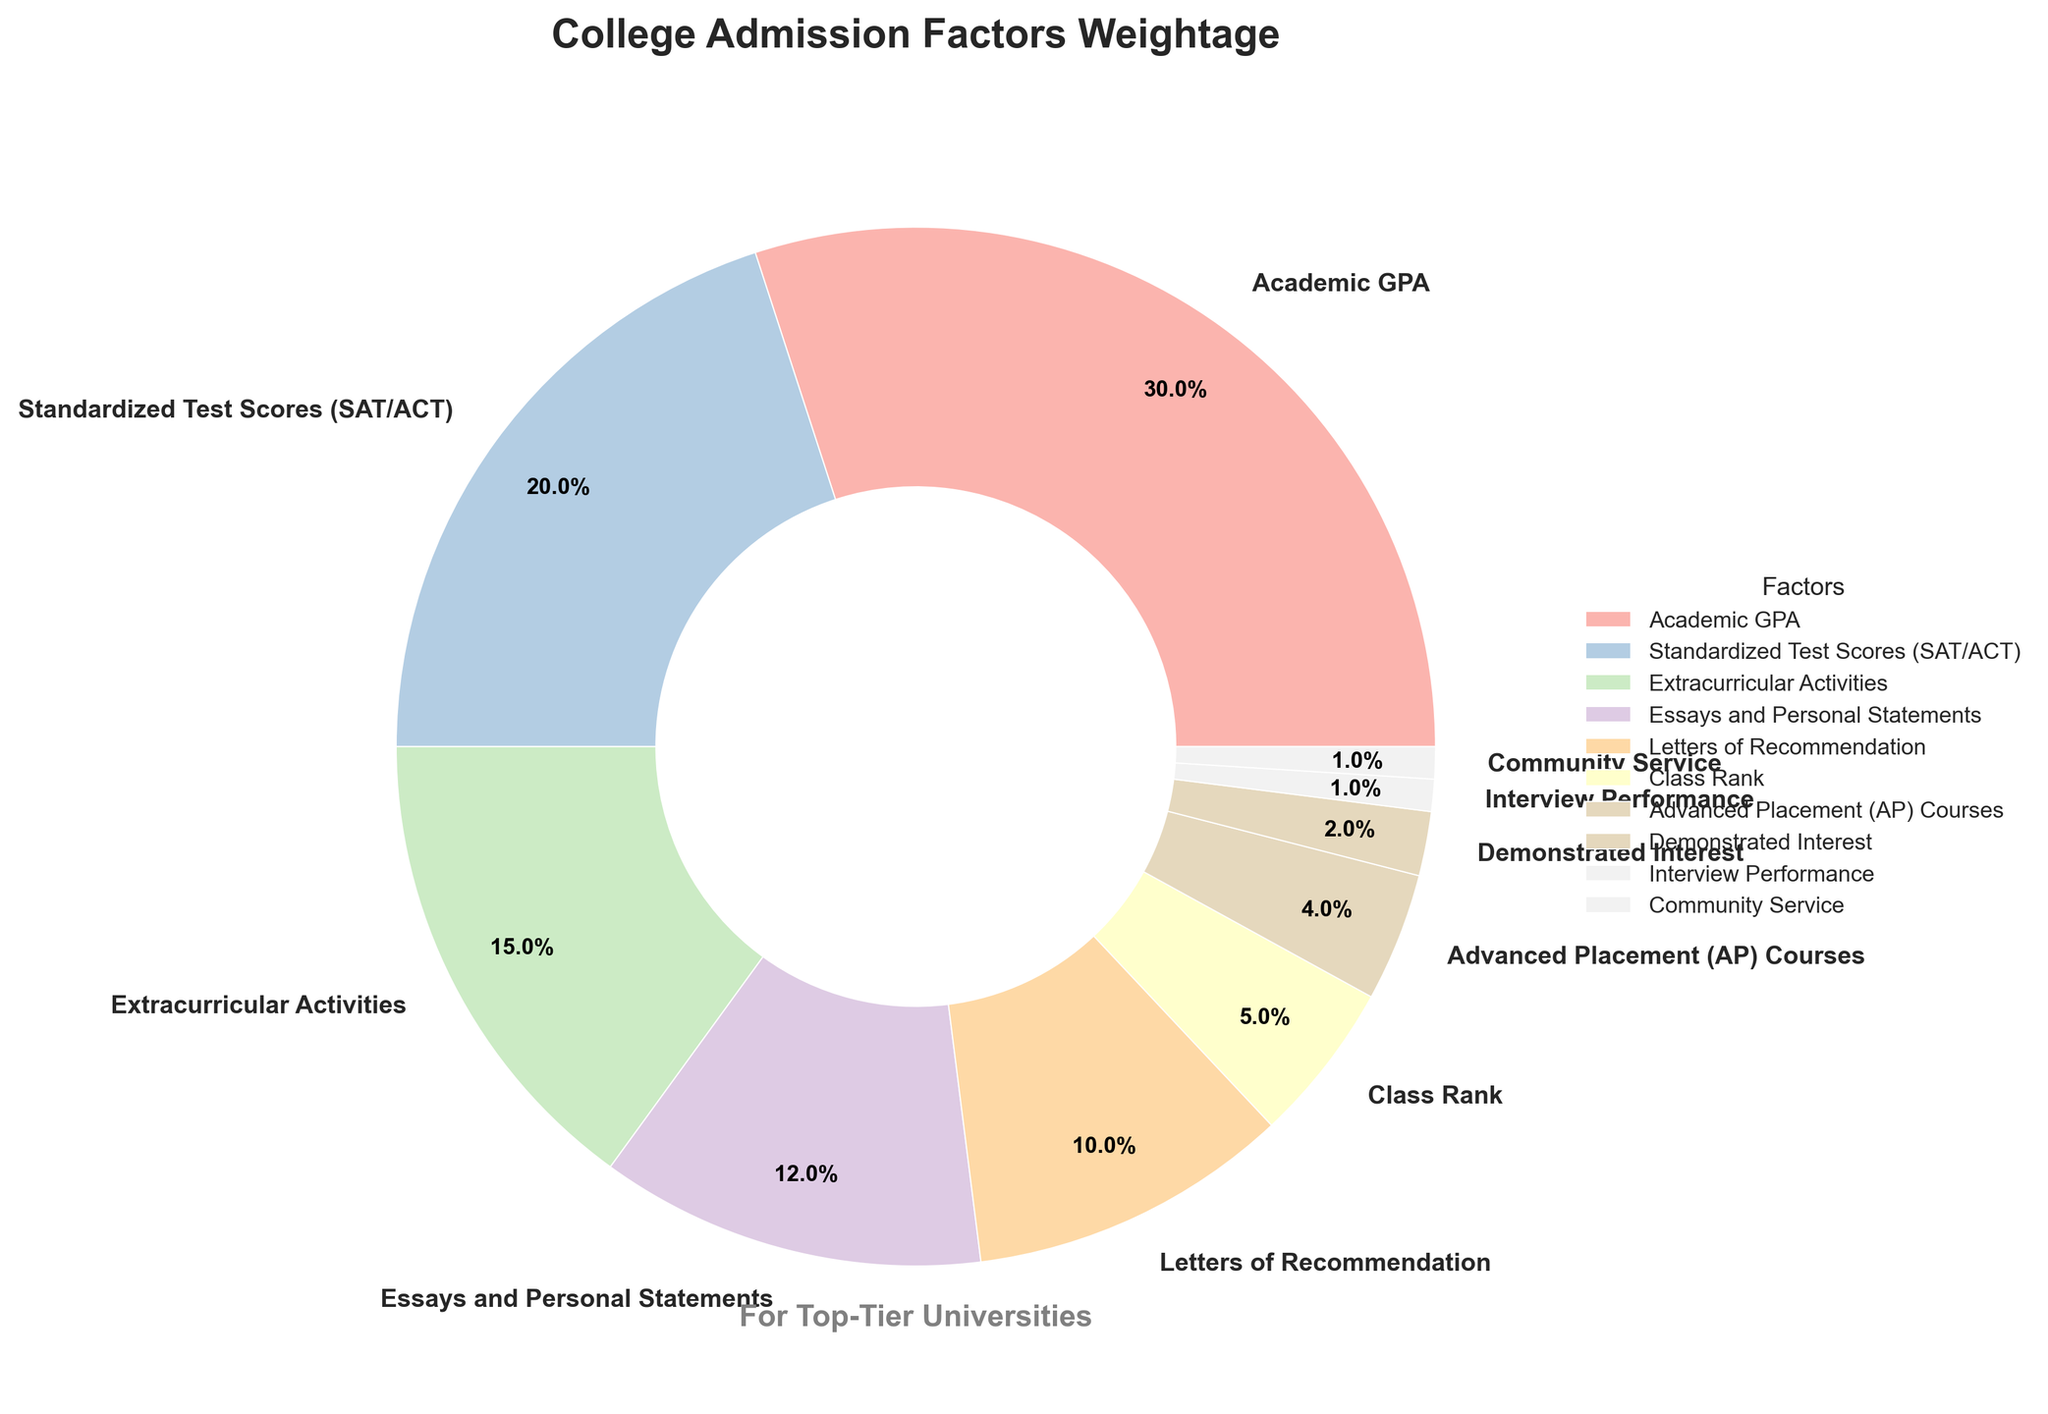What factor contributes the most to college admissions? The factor with the largest segment in the pie chart is "Academic GPA" with a percentage of 30%.
Answer: Academic GPA Which two factors together have the highest weightage percentage? "Academic GPA" (30%) and "Standardized Test Scores (SAT/ACT)" (20%) together have a combined percentage of 30% + 20% = 50%.
Answer: Academic GPA and Standardized Test Scores (SAT/ACT) What is the combined percentage of "Essays and Personal Statements," "Letters of Recommendation," and "Class Rank"? Add the percentages for each factor: "Essays and Personal Statements" (12%), "Letters of Recommendation" (10%), and "Class Rank" (5%). The total is 12% + 10% + 5% = 27%.
Answer: 27% Are "Extracurricular Activities" more important than "Advanced Placement (AP) Courses"? Yes, "Extracurricular Activities" have a percentage of 15%, while "Advanced Placement (AP) Courses" have a lower percentage of 4%.
Answer: Yes Which factor is indicated by the smallest segment in the pie chart? The factor with the smallest segment is "Community Service" and "Interview Performance," each contributing 1% to the total.
Answer: Community Service and Interview Performance How much more important are "Standardized Test Scores (SAT/ACT)" than "Demonstrated Interest"? Subtract the percentage of "Demonstrated Interest" (2%) from "Standardized Test Scores (SAT/ACT)" (20%): 20% - 2% = 18%.
Answer: 18% Which three factors combined have a lower weight than "Standardized Test Scores (SAT/ACT)"? The combined percentage of "Advanced Placement (AP) Courses" (4%), "Demonstrated Interest" (2%), and "Interview Performance" (1%) is 4% + 2% + 1% = 7%, which is lower than "Standardized Test Scores (SAT/ACT)" at 20%.
Answer: Advanced Placement (AP) Courses, Demonstrated Interest, and Interview Performance What is the difference in weightage percentage between "Letters of Recommendation" and "Class Rank"? Subtract the percentage of "Class Rank" (5%) from "Letters of Recommendation" (10%): 10% - 5% = 5%.
Answer: 5% Which factor is visually represented by a pastel color and occupies approximately 15% of the pie chart? The visually pastel-colored segment occupying around 15% corresponds to "Extracurricular Activities."
Answer: Extracurricular Activities 